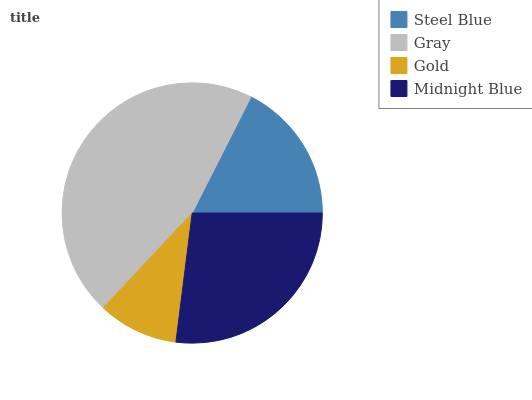Is Gold the minimum?
Answer yes or no. Yes. Is Gray the maximum?
Answer yes or no. Yes. Is Gray the minimum?
Answer yes or no. No. Is Gold the maximum?
Answer yes or no. No. Is Gray greater than Gold?
Answer yes or no. Yes. Is Gold less than Gray?
Answer yes or no. Yes. Is Gold greater than Gray?
Answer yes or no. No. Is Gray less than Gold?
Answer yes or no. No. Is Midnight Blue the high median?
Answer yes or no. Yes. Is Steel Blue the low median?
Answer yes or no. Yes. Is Gray the high median?
Answer yes or no. No. Is Midnight Blue the low median?
Answer yes or no. No. 